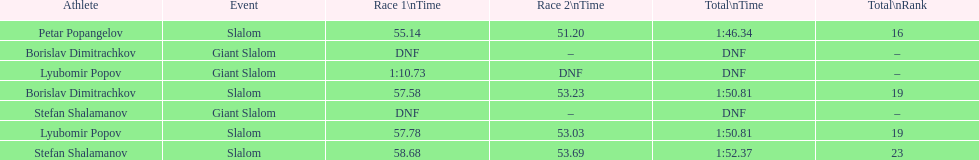What is the number of athletes to finish race one in the giant slalom? 1. 